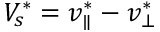<formula> <loc_0><loc_0><loc_500><loc_500>V _ { s } ^ { * } = v _ { \| } ^ { * } - v _ { \bot } ^ { * }</formula> 